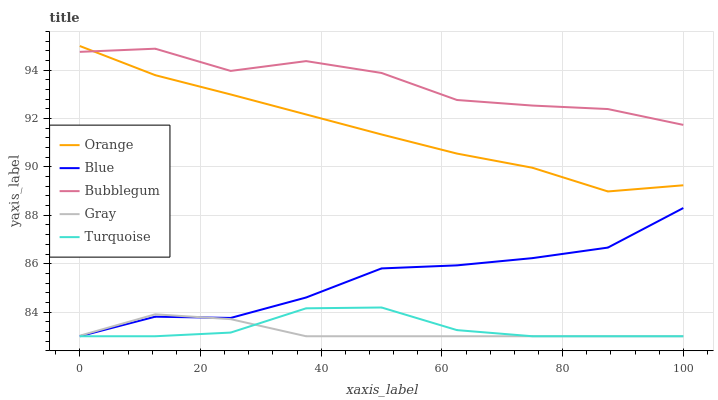Does Gray have the minimum area under the curve?
Answer yes or no. Yes. Does Bubblegum have the maximum area under the curve?
Answer yes or no. Yes. Does Blue have the minimum area under the curve?
Answer yes or no. No. Does Blue have the maximum area under the curve?
Answer yes or no. No. Is Gray the smoothest?
Answer yes or no. Yes. Is Bubblegum the roughest?
Answer yes or no. Yes. Is Blue the smoothest?
Answer yes or no. No. Is Blue the roughest?
Answer yes or no. No. Does Bubblegum have the lowest value?
Answer yes or no. No. Does Blue have the highest value?
Answer yes or no. No. Is Turquoise less than Bubblegum?
Answer yes or no. Yes. Is Orange greater than Gray?
Answer yes or no. Yes. Does Turquoise intersect Bubblegum?
Answer yes or no. No. 